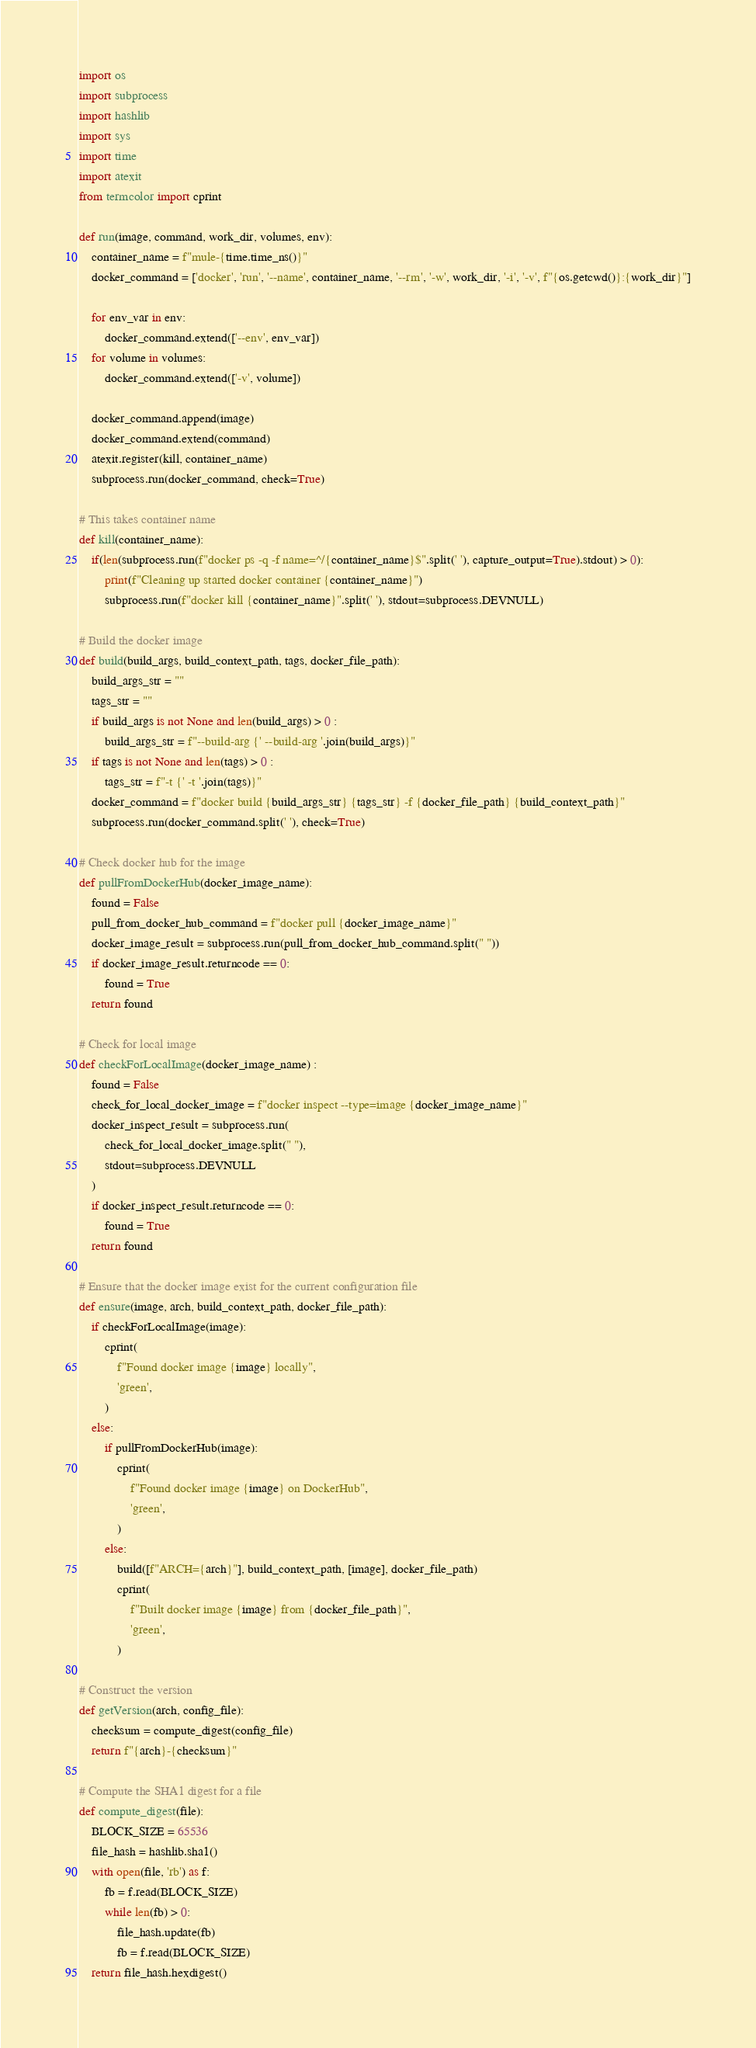<code> <loc_0><loc_0><loc_500><loc_500><_Python_>import os
import subprocess
import hashlib
import sys
import time
import atexit
from termcolor import cprint

def run(image, command, work_dir, volumes, env):
    container_name = f"mule-{time.time_ns()}"
    docker_command = ['docker', 'run', '--name', container_name, '--rm', '-w', work_dir, '-i', '-v', f"{os.getcwd()}:{work_dir}"]

    for env_var in env:
        docker_command.extend(['--env', env_var])
    for volume in volumes:
        docker_command.extend(['-v', volume])

    docker_command.append(image)
    docker_command.extend(command)
    atexit.register(kill, container_name)
    subprocess.run(docker_command, check=True)

# This takes container name
def kill(container_name):
    if(len(subprocess.run(f"docker ps -q -f name=^/{container_name}$".split(' '), capture_output=True).stdout) > 0):
        print(f"Cleaning up started docker container {container_name}")
        subprocess.run(f"docker kill {container_name}".split(' '), stdout=subprocess.DEVNULL)

# Build the docker image
def build(build_args, build_context_path, tags, docker_file_path):
    build_args_str = ""
    tags_str = ""
    if build_args is not None and len(build_args) > 0 :
        build_args_str = f"--build-arg {' --build-arg '.join(build_args)}"
    if tags is not None and len(tags) > 0 :
        tags_str = f"-t {' -t '.join(tags)}"
    docker_command = f"docker build {build_args_str} {tags_str} -f {docker_file_path} {build_context_path}"
    subprocess.run(docker_command.split(' '), check=True)

# Check docker hub for the image
def pullFromDockerHub(docker_image_name):
    found = False
    pull_from_docker_hub_command = f"docker pull {docker_image_name}"
    docker_image_result = subprocess.run(pull_from_docker_hub_command.split(" "))
    if docker_image_result.returncode == 0:
        found = True
    return found

# Check for local image
def checkForLocalImage(docker_image_name) :
    found = False
    check_for_local_docker_image = f"docker inspect --type=image {docker_image_name}"
    docker_inspect_result = subprocess.run(
        check_for_local_docker_image.split(" "),
        stdout=subprocess.DEVNULL
    )
    if docker_inspect_result.returncode == 0:
        found = True
    return found

# Ensure that the docker image exist for the current configuration file
def ensure(image, arch, build_context_path, docker_file_path):
    if checkForLocalImage(image):
        cprint(
            f"Found docker image {image} locally",
            'green',
        )
    else:
        if pullFromDockerHub(image):
            cprint(
                f"Found docker image {image} on DockerHub",
                'green',
            )
        else:
            build([f"ARCH={arch}"], build_context_path, [image], docker_file_path)
            cprint(
                f"Built docker image {image} from {docker_file_path}",
                'green',
            )

# Construct the version
def getVersion(arch, config_file):
    checksum = compute_digest(config_file)
    return f"{arch}-{checksum}"

# Compute the SHA1 digest for a file
def compute_digest(file):
    BLOCK_SIZE = 65536
    file_hash = hashlib.sha1()
    with open(file, 'rb') as f:
        fb = f.read(BLOCK_SIZE)
        while len(fb) > 0:
            file_hash.update(fb)
            fb = f.read(BLOCK_SIZE)
    return file_hash.hexdigest()
</code> 